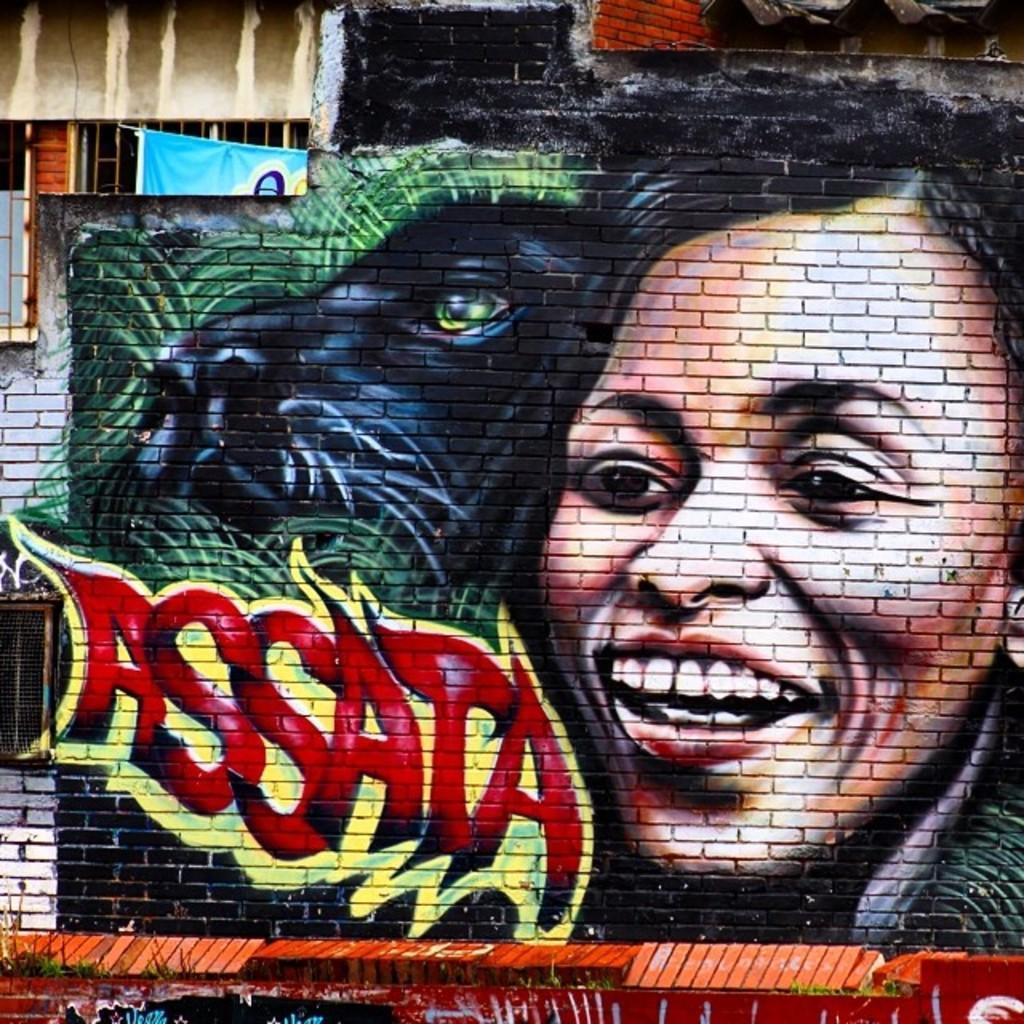How would you summarize this image in a sentence or two? In this image we can see a graffiti painting on the wall. 